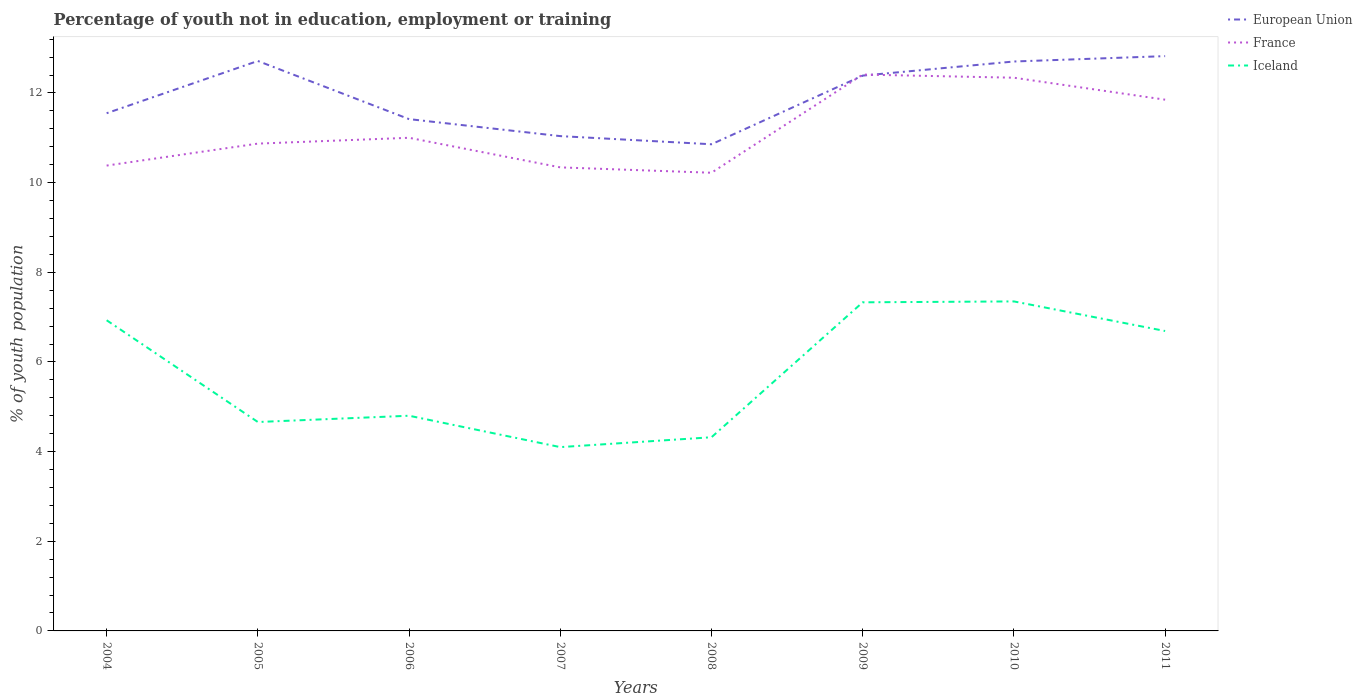Does the line corresponding to Iceland intersect with the line corresponding to France?
Provide a succinct answer. No. Across all years, what is the maximum percentage of unemployed youth population in in European Union?
Give a very brief answer. 10.86. What is the total percentage of unemployed youth population in in Iceland in the graph?
Keep it short and to the point. -2.03. What is the difference between the highest and the second highest percentage of unemployed youth population in in European Union?
Give a very brief answer. 1.97. How many lines are there?
Offer a very short reply. 3. How many years are there in the graph?
Ensure brevity in your answer.  8. Are the values on the major ticks of Y-axis written in scientific E-notation?
Give a very brief answer. No. Where does the legend appear in the graph?
Offer a terse response. Top right. What is the title of the graph?
Your answer should be very brief. Percentage of youth not in education, employment or training. What is the label or title of the Y-axis?
Your response must be concise. % of youth population. What is the % of youth population of European Union in 2004?
Ensure brevity in your answer.  11.55. What is the % of youth population in France in 2004?
Provide a succinct answer. 10.38. What is the % of youth population in Iceland in 2004?
Your answer should be compact. 6.93. What is the % of youth population in European Union in 2005?
Provide a succinct answer. 12.71. What is the % of youth population of France in 2005?
Your response must be concise. 10.87. What is the % of youth population in Iceland in 2005?
Give a very brief answer. 4.66. What is the % of youth population in European Union in 2006?
Offer a terse response. 11.42. What is the % of youth population in Iceland in 2006?
Ensure brevity in your answer.  4.8. What is the % of youth population of European Union in 2007?
Keep it short and to the point. 11.04. What is the % of youth population of France in 2007?
Offer a very short reply. 10.34. What is the % of youth population in Iceland in 2007?
Offer a terse response. 4.1. What is the % of youth population of European Union in 2008?
Your response must be concise. 10.86. What is the % of youth population of France in 2008?
Offer a very short reply. 10.22. What is the % of youth population in Iceland in 2008?
Offer a terse response. 4.32. What is the % of youth population of European Union in 2009?
Your answer should be very brief. 12.39. What is the % of youth population in France in 2009?
Offer a very short reply. 12.41. What is the % of youth population of Iceland in 2009?
Ensure brevity in your answer.  7.33. What is the % of youth population in European Union in 2010?
Make the answer very short. 12.7. What is the % of youth population in France in 2010?
Your answer should be very brief. 12.34. What is the % of youth population in Iceland in 2010?
Keep it short and to the point. 7.35. What is the % of youth population in European Union in 2011?
Your answer should be compact. 12.82. What is the % of youth population in France in 2011?
Provide a succinct answer. 11.85. What is the % of youth population of Iceland in 2011?
Your answer should be very brief. 6.69. Across all years, what is the maximum % of youth population in European Union?
Your answer should be very brief. 12.82. Across all years, what is the maximum % of youth population in France?
Give a very brief answer. 12.41. Across all years, what is the maximum % of youth population in Iceland?
Ensure brevity in your answer.  7.35. Across all years, what is the minimum % of youth population of European Union?
Make the answer very short. 10.86. Across all years, what is the minimum % of youth population of France?
Give a very brief answer. 10.22. Across all years, what is the minimum % of youth population of Iceland?
Your answer should be very brief. 4.1. What is the total % of youth population in European Union in the graph?
Offer a terse response. 95.48. What is the total % of youth population in France in the graph?
Your answer should be very brief. 89.41. What is the total % of youth population of Iceland in the graph?
Your answer should be very brief. 46.18. What is the difference between the % of youth population of European Union in 2004 and that in 2005?
Provide a short and direct response. -1.17. What is the difference between the % of youth population of France in 2004 and that in 2005?
Offer a terse response. -0.49. What is the difference between the % of youth population in Iceland in 2004 and that in 2005?
Ensure brevity in your answer.  2.27. What is the difference between the % of youth population in European Union in 2004 and that in 2006?
Give a very brief answer. 0.13. What is the difference between the % of youth population of France in 2004 and that in 2006?
Offer a terse response. -0.62. What is the difference between the % of youth population of Iceland in 2004 and that in 2006?
Your answer should be compact. 2.13. What is the difference between the % of youth population of European Union in 2004 and that in 2007?
Offer a terse response. 0.51. What is the difference between the % of youth population of Iceland in 2004 and that in 2007?
Keep it short and to the point. 2.83. What is the difference between the % of youth population in European Union in 2004 and that in 2008?
Your answer should be very brief. 0.69. What is the difference between the % of youth population in France in 2004 and that in 2008?
Your response must be concise. 0.16. What is the difference between the % of youth population in Iceland in 2004 and that in 2008?
Your response must be concise. 2.61. What is the difference between the % of youth population of European Union in 2004 and that in 2009?
Your answer should be compact. -0.84. What is the difference between the % of youth population in France in 2004 and that in 2009?
Your answer should be compact. -2.03. What is the difference between the % of youth population in European Union in 2004 and that in 2010?
Provide a succinct answer. -1.15. What is the difference between the % of youth population in France in 2004 and that in 2010?
Offer a very short reply. -1.96. What is the difference between the % of youth population of Iceland in 2004 and that in 2010?
Keep it short and to the point. -0.42. What is the difference between the % of youth population of European Union in 2004 and that in 2011?
Your answer should be compact. -1.27. What is the difference between the % of youth population of France in 2004 and that in 2011?
Your response must be concise. -1.47. What is the difference between the % of youth population of Iceland in 2004 and that in 2011?
Offer a terse response. 0.24. What is the difference between the % of youth population in European Union in 2005 and that in 2006?
Your response must be concise. 1.3. What is the difference between the % of youth population in France in 2005 and that in 2006?
Provide a short and direct response. -0.13. What is the difference between the % of youth population of Iceland in 2005 and that in 2006?
Make the answer very short. -0.14. What is the difference between the % of youth population in European Union in 2005 and that in 2007?
Keep it short and to the point. 1.68. What is the difference between the % of youth population in France in 2005 and that in 2007?
Provide a short and direct response. 0.53. What is the difference between the % of youth population of Iceland in 2005 and that in 2007?
Ensure brevity in your answer.  0.56. What is the difference between the % of youth population of European Union in 2005 and that in 2008?
Your answer should be compact. 1.86. What is the difference between the % of youth population of France in 2005 and that in 2008?
Offer a very short reply. 0.65. What is the difference between the % of youth population in Iceland in 2005 and that in 2008?
Give a very brief answer. 0.34. What is the difference between the % of youth population in European Union in 2005 and that in 2009?
Provide a succinct answer. 0.33. What is the difference between the % of youth population in France in 2005 and that in 2009?
Provide a short and direct response. -1.54. What is the difference between the % of youth population in Iceland in 2005 and that in 2009?
Provide a short and direct response. -2.67. What is the difference between the % of youth population of European Union in 2005 and that in 2010?
Give a very brief answer. 0.01. What is the difference between the % of youth population of France in 2005 and that in 2010?
Provide a short and direct response. -1.47. What is the difference between the % of youth population in Iceland in 2005 and that in 2010?
Make the answer very short. -2.69. What is the difference between the % of youth population in European Union in 2005 and that in 2011?
Your answer should be very brief. -0.11. What is the difference between the % of youth population of France in 2005 and that in 2011?
Your answer should be very brief. -0.98. What is the difference between the % of youth population in Iceland in 2005 and that in 2011?
Your answer should be very brief. -2.03. What is the difference between the % of youth population of European Union in 2006 and that in 2007?
Provide a short and direct response. 0.38. What is the difference between the % of youth population in France in 2006 and that in 2007?
Ensure brevity in your answer.  0.66. What is the difference between the % of youth population of European Union in 2006 and that in 2008?
Give a very brief answer. 0.56. What is the difference between the % of youth population of France in 2006 and that in 2008?
Keep it short and to the point. 0.78. What is the difference between the % of youth population of Iceland in 2006 and that in 2008?
Your answer should be very brief. 0.48. What is the difference between the % of youth population of European Union in 2006 and that in 2009?
Offer a very short reply. -0.97. What is the difference between the % of youth population in France in 2006 and that in 2009?
Provide a short and direct response. -1.41. What is the difference between the % of youth population in Iceland in 2006 and that in 2009?
Make the answer very short. -2.53. What is the difference between the % of youth population in European Union in 2006 and that in 2010?
Provide a short and direct response. -1.29. What is the difference between the % of youth population of France in 2006 and that in 2010?
Give a very brief answer. -1.34. What is the difference between the % of youth population in Iceland in 2006 and that in 2010?
Offer a terse response. -2.55. What is the difference between the % of youth population of European Union in 2006 and that in 2011?
Give a very brief answer. -1.41. What is the difference between the % of youth population of France in 2006 and that in 2011?
Your answer should be compact. -0.85. What is the difference between the % of youth population of Iceland in 2006 and that in 2011?
Make the answer very short. -1.89. What is the difference between the % of youth population in European Union in 2007 and that in 2008?
Ensure brevity in your answer.  0.18. What is the difference between the % of youth population in France in 2007 and that in 2008?
Make the answer very short. 0.12. What is the difference between the % of youth population in Iceland in 2007 and that in 2008?
Your answer should be compact. -0.22. What is the difference between the % of youth population of European Union in 2007 and that in 2009?
Make the answer very short. -1.35. What is the difference between the % of youth population of France in 2007 and that in 2009?
Keep it short and to the point. -2.07. What is the difference between the % of youth population of Iceland in 2007 and that in 2009?
Provide a succinct answer. -3.23. What is the difference between the % of youth population in European Union in 2007 and that in 2010?
Your answer should be compact. -1.66. What is the difference between the % of youth population in France in 2007 and that in 2010?
Give a very brief answer. -2. What is the difference between the % of youth population in Iceland in 2007 and that in 2010?
Provide a succinct answer. -3.25. What is the difference between the % of youth population in European Union in 2007 and that in 2011?
Offer a terse response. -1.78. What is the difference between the % of youth population in France in 2007 and that in 2011?
Offer a terse response. -1.51. What is the difference between the % of youth population of Iceland in 2007 and that in 2011?
Keep it short and to the point. -2.59. What is the difference between the % of youth population in European Union in 2008 and that in 2009?
Offer a very short reply. -1.53. What is the difference between the % of youth population of France in 2008 and that in 2009?
Give a very brief answer. -2.19. What is the difference between the % of youth population of Iceland in 2008 and that in 2009?
Your response must be concise. -3.01. What is the difference between the % of youth population of European Union in 2008 and that in 2010?
Ensure brevity in your answer.  -1.85. What is the difference between the % of youth population in France in 2008 and that in 2010?
Provide a succinct answer. -2.12. What is the difference between the % of youth population in Iceland in 2008 and that in 2010?
Provide a short and direct response. -3.03. What is the difference between the % of youth population of European Union in 2008 and that in 2011?
Ensure brevity in your answer.  -1.97. What is the difference between the % of youth population of France in 2008 and that in 2011?
Make the answer very short. -1.63. What is the difference between the % of youth population of Iceland in 2008 and that in 2011?
Offer a very short reply. -2.37. What is the difference between the % of youth population in European Union in 2009 and that in 2010?
Ensure brevity in your answer.  -0.31. What is the difference between the % of youth population of France in 2009 and that in 2010?
Ensure brevity in your answer.  0.07. What is the difference between the % of youth population in Iceland in 2009 and that in 2010?
Make the answer very short. -0.02. What is the difference between the % of youth population of European Union in 2009 and that in 2011?
Make the answer very short. -0.43. What is the difference between the % of youth population in France in 2009 and that in 2011?
Provide a short and direct response. 0.56. What is the difference between the % of youth population of Iceland in 2009 and that in 2011?
Offer a very short reply. 0.64. What is the difference between the % of youth population of European Union in 2010 and that in 2011?
Offer a very short reply. -0.12. What is the difference between the % of youth population in France in 2010 and that in 2011?
Your answer should be compact. 0.49. What is the difference between the % of youth population in Iceland in 2010 and that in 2011?
Ensure brevity in your answer.  0.66. What is the difference between the % of youth population of European Union in 2004 and the % of youth population of France in 2005?
Your response must be concise. 0.68. What is the difference between the % of youth population in European Union in 2004 and the % of youth population in Iceland in 2005?
Give a very brief answer. 6.89. What is the difference between the % of youth population of France in 2004 and the % of youth population of Iceland in 2005?
Keep it short and to the point. 5.72. What is the difference between the % of youth population of European Union in 2004 and the % of youth population of France in 2006?
Provide a succinct answer. 0.55. What is the difference between the % of youth population in European Union in 2004 and the % of youth population in Iceland in 2006?
Ensure brevity in your answer.  6.75. What is the difference between the % of youth population of France in 2004 and the % of youth population of Iceland in 2006?
Your answer should be very brief. 5.58. What is the difference between the % of youth population in European Union in 2004 and the % of youth population in France in 2007?
Keep it short and to the point. 1.21. What is the difference between the % of youth population in European Union in 2004 and the % of youth population in Iceland in 2007?
Your answer should be very brief. 7.45. What is the difference between the % of youth population in France in 2004 and the % of youth population in Iceland in 2007?
Make the answer very short. 6.28. What is the difference between the % of youth population of European Union in 2004 and the % of youth population of France in 2008?
Keep it short and to the point. 1.33. What is the difference between the % of youth population of European Union in 2004 and the % of youth population of Iceland in 2008?
Provide a short and direct response. 7.23. What is the difference between the % of youth population in France in 2004 and the % of youth population in Iceland in 2008?
Offer a terse response. 6.06. What is the difference between the % of youth population of European Union in 2004 and the % of youth population of France in 2009?
Your answer should be very brief. -0.86. What is the difference between the % of youth population in European Union in 2004 and the % of youth population in Iceland in 2009?
Keep it short and to the point. 4.22. What is the difference between the % of youth population of France in 2004 and the % of youth population of Iceland in 2009?
Offer a very short reply. 3.05. What is the difference between the % of youth population of European Union in 2004 and the % of youth population of France in 2010?
Your response must be concise. -0.79. What is the difference between the % of youth population of European Union in 2004 and the % of youth population of Iceland in 2010?
Your answer should be compact. 4.2. What is the difference between the % of youth population of France in 2004 and the % of youth population of Iceland in 2010?
Keep it short and to the point. 3.03. What is the difference between the % of youth population of European Union in 2004 and the % of youth population of France in 2011?
Offer a terse response. -0.3. What is the difference between the % of youth population of European Union in 2004 and the % of youth population of Iceland in 2011?
Your answer should be very brief. 4.86. What is the difference between the % of youth population of France in 2004 and the % of youth population of Iceland in 2011?
Your answer should be very brief. 3.69. What is the difference between the % of youth population of European Union in 2005 and the % of youth population of France in 2006?
Give a very brief answer. 1.71. What is the difference between the % of youth population in European Union in 2005 and the % of youth population in Iceland in 2006?
Ensure brevity in your answer.  7.91. What is the difference between the % of youth population of France in 2005 and the % of youth population of Iceland in 2006?
Make the answer very short. 6.07. What is the difference between the % of youth population in European Union in 2005 and the % of youth population in France in 2007?
Provide a short and direct response. 2.37. What is the difference between the % of youth population in European Union in 2005 and the % of youth population in Iceland in 2007?
Your answer should be compact. 8.61. What is the difference between the % of youth population of France in 2005 and the % of youth population of Iceland in 2007?
Your answer should be very brief. 6.77. What is the difference between the % of youth population in European Union in 2005 and the % of youth population in France in 2008?
Your answer should be compact. 2.49. What is the difference between the % of youth population in European Union in 2005 and the % of youth population in Iceland in 2008?
Offer a terse response. 8.39. What is the difference between the % of youth population in France in 2005 and the % of youth population in Iceland in 2008?
Give a very brief answer. 6.55. What is the difference between the % of youth population of European Union in 2005 and the % of youth population of France in 2009?
Ensure brevity in your answer.  0.3. What is the difference between the % of youth population of European Union in 2005 and the % of youth population of Iceland in 2009?
Offer a terse response. 5.38. What is the difference between the % of youth population in France in 2005 and the % of youth population in Iceland in 2009?
Your response must be concise. 3.54. What is the difference between the % of youth population of European Union in 2005 and the % of youth population of France in 2010?
Keep it short and to the point. 0.37. What is the difference between the % of youth population in European Union in 2005 and the % of youth population in Iceland in 2010?
Your answer should be very brief. 5.36. What is the difference between the % of youth population of France in 2005 and the % of youth population of Iceland in 2010?
Your response must be concise. 3.52. What is the difference between the % of youth population of European Union in 2005 and the % of youth population of France in 2011?
Make the answer very short. 0.86. What is the difference between the % of youth population in European Union in 2005 and the % of youth population in Iceland in 2011?
Offer a very short reply. 6.02. What is the difference between the % of youth population of France in 2005 and the % of youth population of Iceland in 2011?
Make the answer very short. 4.18. What is the difference between the % of youth population in European Union in 2006 and the % of youth population in France in 2007?
Offer a very short reply. 1.08. What is the difference between the % of youth population in European Union in 2006 and the % of youth population in Iceland in 2007?
Provide a succinct answer. 7.32. What is the difference between the % of youth population of European Union in 2006 and the % of youth population of France in 2008?
Your answer should be very brief. 1.2. What is the difference between the % of youth population in European Union in 2006 and the % of youth population in Iceland in 2008?
Your answer should be very brief. 7.1. What is the difference between the % of youth population in France in 2006 and the % of youth population in Iceland in 2008?
Ensure brevity in your answer.  6.68. What is the difference between the % of youth population of European Union in 2006 and the % of youth population of France in 2009?
Ensure brevity in your answer.  -0.99. What is the difference between the % of youth population in European Union in 2006 and the % of youth population in Iceland in 2009?
Give a very brief answer. 4.09. What is the difference between the % of youth population of France in 2006 and the % of youth population of Iceland in 2009?
Your answer should be compact. 3.67. What is the difference between the % of youth population in European Union in 2006 and the % of youth population in France in 2010?
Offer a terse response. -0.92. What is the difference between the % of youth population of European Union in 2006 and the % of youth population of Iceland in 2010?
Your response must be concise. 4.07. What is the difference between the % of youth population in France in 2006 and the % of youth population in Iceland in 2010?
Ensure brevity in your answer.  3.65. What is the difference between the % of youth population in European Union in 2006 and the % of youth population in France in 2011?
Your answer should be very brief. -0.43. What is the difference between the % of youth population of European Union in 2006 and the % of youth population of Iceland in 2011?
Provide a short and direct response. 4.73. What is the difference between the % of youth population of France in 2006 and the % of youth population of Iceland in 2011?
Offer a very short reply. 4.31. What is the difference between the % of youth population of European Union in 2007 and the % of youth population of France in 2008?
Offer a terse response. 0.82. What is the difference between the % of youth population of European Union in 2007 and the % of youth population of Iceland in 2008?
Ensure brevity in your answer.  6.72. What is the difference between the % of youth population in France in 2007 and the % of youth population in Iceland in 2008?
Provide a short and direct response. 6.02. What is the difference between the % of youth population of European Union in 2007 and the % of youth population of France in 2009?
Provide a succinct answer. -1.37. What is the difference between the % of youth population in European Union in 2007 and the % of youth population in Iceland in 2009?
Your answer should be compact. 3.71. What is the difference between the % of youth population in France in 2007 and the % of youth population in Iceland in 2009?
Offer a terse response. 3.01. What is the difference between the % of youth population in European Union in 2007 and the % of youth population in France in 2010?
Offer a very short reply. -1.3. What is the difference between the % of youth population of European Union in 2007 and the % of youth population of Iceland in 2010?
Give a very brief answer. 3.69. What is the difference between the % of youth population in France in 2007 and the % of youth population in Iceland in 2010?
Ensure brevity in your answer.  2.99. What is the difference between the % of youth population of European Union in 2007 and the % of youth population of France in 2011?
Ensure brevity in your answer.  -0.81. What is the difference between the % of youth population of European Union in 2007 and the % of youth population of Iceland in 2011?
Offer a very short reply. 4.35. What is the difference between the % of youth population in France in 2007 and the % of youth population in Iceland in 2011?
Provide a succinct answer. 3.65. What is the difference between the % of youth population of European Union in 2008 and the % of youth population of France in 2009?
Offer a very short reply. -1.55. What is the difference between the % of youth population in European Union in 2008 and the % of youth population in Iceland in 2009?
Your answer should be very brief. 3.53. What is the difference between the % of youth population of France in 2008 and the % of youth population of Iceland in 2009?
Your response must be concise. 2.89. What is the difference between the % of youth population of European Union in 2008 and the % of youth population of France in 2010?
Your response must be concise. -1.48. What is the difference between the % of youth population in European Union in 2008 and the % of youth population in Iceland in 2010?
Your answer should be very brief. 3.51. What is the difference between the % of youth population in France in 2008 and the % of youth population in Iceland in 2010?
Your response must be concise. 2.87. What is the difference between the % of youth population of European Union in 2008 and the % of youth population of France in 2011?
Give a very brief answer. -0.99. What is the difference between the % of youth population in European Union in 2008 and the % of youth population in Iceland in 2011?
Offer a very short reply. 4.17. What is the difference between the % of youth population in France in 2008 and the % of youth population in Iceland in 2011?
Offer a terse response. 3.53. What is the difference between the % of youth population in European Union in 2009 and the % of youth population in France in 2010?
Ensure brevity in your answer.  0.05. What is the difference between the % of youth population in European Union in 2009 and the % of youth population in Iceland in 2010?
Offer a terse response. 5.04. What is the difference between the % of youth population in France in 2009 and the % of youth population in Iceland in 2010?
Offer a terse response. 5.06. What is the difference between the % of youth population in European Union in 2009 and the % of youth population in France in 2011?
Offer a terse response. 0.54. What is the difference between the % of youth population in European Union in 2009 and the % of youth population in Iceland in 2011?
Offer a very short reply. 5.7. What is the difference between the % of youth population in France in 2009 and the % of youth population in Iceland in 2011?
Make the answer very short. 5.72. What is the difference between the % of youth population of European Union in 2010 and the % of youth population of France in 2011?
Provide a short and direct response. 0.85. What is the difference between the % of youth population of European Union in 2010 and the % of youth population of Iceland in 2011?
Keep it short and to the point. 6.01. What is the difference between the % of youth population in France in 2010 and the % of youth population in Iceland in 2011?
Offer a very short reply. 5.65. What is the average % of youth population of European Union per year?
Your response must be concise. 11.94. What is the average % of youth population in France per year?
Give a very brief answer. 11.18. What is the average % of youth population in Iceland per year?
Offer a terse response. 5.77. In the year 2004, what is the difference between the % of youth population in European Union and % of youth population in France?
Provide a short and direct response. 1.17. In the year 2004, what is the difference between the % of youth population in European Union and % of youth population in Iceland?
Ensure brevity in your answer.  4.62. In the year 2004, what is the difference between the % of youth population in France and % of youth population in Iceland?
Your answer should be compact. 3.45. In the year 2005, what is the difference between the % of youth population in European Union and % of youth population in France?
Ensure brevity in your answer.  1.84. In the year 2005, what is the difference between the % of youth population of European Union and % of youth population of Iceland?
Your response must be concise. 8.05. In the year 2005, what is the difference between the % of youth population in France and % of youth population in Iceland?
Provide a short and direct response. 6.21. In the year 2006, what is the difference between the % of youth population in European Union and % of youth population in France?
Ensure brevity in your answer.  0.42. In the year 2006, what is the difference between the % of youth population of European Union and % of youth population of Iceland?
Your answer should be compact. 6.62. In the year 2007, what is the difference between the % of youth population of European Union and % of youth population of France?
Offer a terse response. 0.7. In the year 2007, what is the difference between the % of youth population of European Union and % of youth population of Iceland?
Offer a terse response. 6.94. In the year 2007, what is the difference between the % of youth population in France and % of youth population in Iceland?
Provide a succinct answer. 6.24. In the year 2008, what is the difference between the % of youth population in European Union and % of youth population in France?
Offer a terse response. 0.64. In the year 2008, what is the difference between the % of youth population in European Union and % of youth population in Iceland?
Ensure brevity in your answer.  6.54. In the year 2009, what is the difference between the % of youth population of European Union and % of youth population of France?
Ensure brevity in your answer.  -0.02. In the year 2009, what is the difference between the % of youth population in European Union and % of youth population in Iceland?
Your answer should be compact. 5.06. In the year 2009, what is the difference between the % of youth population in France and % of youth population in Iceland?
Offer a terse response. 5.08. In the year 2010, what is the difference between the % of youth population of European Union and % of youth population of France?
Offer a terse response. 0.36. In the year 2010, what is the difference between the % of youth population of European Union and % of youth population of Iceland?
Provide a succinct answer. 5.35. In the year 2010, what is the difference between the % of youth population of France and % of youth population of Iceland?
Your answer should be very brief. 4.99. In the year 2011, what is the difference between the % of youth population of European Union and % of youth population of France?
Your answer should be compact. 0.97. In the year 2011, what is the difference between the % of youth population in European Union and % of youth population in Iceland?
Your response must be concise. 6.13. In the year 2011, what is the difference between the % of youth population in France and % of youth population in Iceland?
Your answer should be very brief. 5.16. What is the ratio of the % of youth population of European Union in 2004 to that in 2005?
Your response must be concise. 0.91. What is the ratio of the % of youth population in France in 2004 to that in 2005?
Your answer should be very brief. 0.95. What is the ratio of the % of youth population of Iceland in 2004 to that in 2005?
Your response must be concise. 1.49. What is the ratio of the % of youth population in European Union in 2004 to that in 2006?
Ensure brevity in your answer.  1.01. What is the ratio of the % of youth population in France in 2004 to that in 2006?
Your answer should be compact. 0.94. What is the ratio of the % of youth population of Iceland in 2004 to that in 2006?
Provide a succinct answer. 1.44. What is the ratio of the % of youth population in European Union in 2004 to that in 2007?
Your answer should be very brief. 1.05. What is the ratio of the % of youth population in Iceland in 2004 to that in 2007?
Give a very brief answer. 1.69. What is the ratio of the % of youth population of European Union in 2004 to that in 2008?
Ensure brevity in your answer.  1.06. What is the ratio of the % of youth population of France in 2004 to that in 2008?
Ensure brevity in your answer.  1.02. What is the ratio of the % of youth population of Iceland in 2004 to that in 2008?
Your answer should be very brief. 1.6. What is the ratio of the % of youth population in European Union in 2004 to that in 2009?
Give a very brief answer. 0.93. What is the ratio of the % of youth population of France in 2004 to that in 2009?
Your answer should be very brief. 0.84. What is the ratio of the % of youth population in Iceland in 2004 to that in 2009?
Your response must be concise. 0.95. What is the ratio of the % of youth population of European Union in 2004 to that in 2010?
Make the answer very short. 0.91. What is the ratio of the % of youth population in France in 2004 to that in 2010?
Offer a very short reply. 0.84. What is the ratio of the % of youth population of Iceland in 2004 to that in 2010?
Offer a terse response. 0.94. What is the ratio of the % of youth population in European Union in 2004 to that in 2011?
Keep it short and to the point. 0.9. What is the ratio of the % of youth population in France in 2004 to that in 2011?
Your answer should be very brief. 0.88. What is the ratio of the % of youth population in Iceland in 2004 to that in 2011?
Offer a terse response. 1.04. What is the ratio of the % of youth population in European Union in 2005 to that in 2006?
Offer a terse response. 1.11. What is the ratio of the % of youth population in Iceland in 2005 to that in 2006?
Offer a terse response. 0.97. What is the ratio of the % of youth population in European Union in 2005 to that in 2007?
Offer a very short reply. 1.15. What is the ratio of the % of youth population in France in 2005 to that in 2007?
Your answer should be compact. 1.05. What is the ratio of the % of youth population of Iceland in 2005 to that in 2007?
Ensure brevity in your answer.  1.14. What is the ratio of the % of youth population of European Union in 2005 to that in 2008?
Ensure brevity in your answer.  1.17. What is the ratio of the % of youth population in France in 2005 to that in 2008?
Provide a short and direct response. 1.06. What is the ratio of the % of youth population of Iceland in 2005 to that in 2008?
Keep it short and to the point. 1.08. What is the ratio of the % of youth population of European Union in 2005 to that in 2009?
Keep it short and to the point. 1.03. What is the ratio of the % of youth population in France in 2005 to that in 2009?
Make the answer very short. 0.88. What is the ratio of the % of youth population in Iceland in 2005 to that in 2009?
Provide a short and direct response. 0.64. What is the ratio of the % of youth population in France in 2005 to that in 2010?
Offer a terse response. 0.88. What is the ratio of the % of youth population in Iceland in 2005 to that in 2010?
Provide a succinct answer. 0.63. What is the ratio of the % of youth population of European Union in 2005 to that in 2011?
Provide a short and direct response. 0.99. What is the ratio of the % of youth population in France in 2005 to that in 2011?
Your response must be concise. 0.92. What is the ratio of the % of youth population of Iceland in 2005 to that in 2011?
Your answer should be very brief. 0.7. What is the ratio of the % of youth population of European Union in 2006 to that in 2007?
Ensure brevity in your answer.  1.03. What is the ratio of the % of youth population of France in 2006 to that in 2007?
Ensure brevity in your answer.  1.06. What is the ratio of the % of youth population of Iceland in 2006 to that in 2007?
Your response must be concise. 1.17. What is the ratio of the % of youth population of European Union in 2006 to that in 2008?
Provide a short and direct response. 1.05. What is the ratio of the % of youth population in France in 2006 to that in 2008?
Offer a very short reply. 1.08. What is the ratio of the % of youth population in Iceland in 2006 to that in 2008?
Provide a short and direct response. 1.11. What is the ratio of the % of youth population of European Union in 2006 to that in 2009?
Your answer should be compact. 0.92. What is the ratio of the % of youth population in France in 2006 to that in 2009?
Ensure brevity in your answer.  0.89. What is the ratio of the % of youth population in Iceland in 2006 to that in 2009?
Offer a very short reply. 0.65. What is the ratio of the % of youth population in European Union in 2006 to that in 2010?
Give a very brief answer. 0.9. What is the ratio of the % of youth population of France in 2006 to that in 2010?
Provide a short and direct response. 0.89. What is the ratio of the % of youth population of Iceland in 2006 to that in 2010?
Offer a very short reply. 0.65. What is the ratio of the % of youth population in European Union in 2006 to that in 2011?
Your response must be concise. 0.89. What is the ratio of the % of youth population in France in 2006 to that in 2011?
Your response must be concise. 0.93. What is the ratio of the % of youth population in Iceland in 2006 to that in 2011?
Your answer should be compact. 0.72. What is the ratio of the % of youth population of European Union in 2007 to that in 2008?
Provide a succinct answer. 1.02. What is the ratio of the % of youth population in France in 2007 to that in 2008?
Give a very brief answer. 1.01. What is the ratio of the % of youth population of Iceland in 2007 to that in 2008?
Ensure brevity in your answer.  0.95. What is the ratio of the % of youth population of European Union in 2007 to that in 2009?
Your answer should be compact. 0.89. What is the ratio of the % of youth population in France in 2007 to that in 2009?
Offer a terse response. 0.83. What is the ratio of the % of youth population of Iceland in 2007 to that in 2009?
Make the answer very short. 0.56. What is the ratio of the % of youth population of European Union in 2007 to that in 2010?
Keep it short and to the point. 0.87. What is the ratio of the % of youth population of France in 2007 to that in 2010?
Your answer should be very brief. 0.84. What is the ratio of the % of youth population in Iceland in 2007 to that in 2010?
Your answer should be compact. 0.56. What is the ratio of the % of youth population of European Union in 2007 to that in 2011?
Offer a very short reply. 0.86. What is the ratio of the % of youth population of France in 2007 to that in 2011?
Your response must be concise. 0.87. What is the ratio of the % of youth population of Iceland in 2007 to that in 2011?
Your response must be concise. 0.61. What is the ratio of the % of youth population of European Union in 2008 to that in 2009?
Ensure brevity in your answer.  0.88. What is the ratio of the % of youth population in France in 2008 to that in 2009?
Give a very brief answer. 0.82. What is the ratio of the % of youth population in Iceland in 2008 to that in 2009?
Make the answer very short. 0.59. What is the ratio of the % of youth population of European Union in 2008 to that in 2010?
Give a very brief answer. 0.85. What is the ratio of the % of youth population in France in 2008 to that in 2010?
Offer a terse response. 0.83. What is the ratio of the % of youth population in Iceland in 2008 to that in 2010?
Provide a succinct answer. 0.59. What is the ratio of the % of youth population of European Union in 2008 to that in 2011?
Provide a succinct answer. 0.85. What is the ratio of the % of youth population of France in 2008 to that in 2011?
Your answer should be very brief. 0.86. What is the ratio of the % of youth population in Iceland in 2008 to that in 2011?
Your answer should be very brief. 0.65. What is the ratio of the % of youth population of European Union in 2009 to that in 2010?
Offer a terse response. 0.98. What is the ratio of the % of youth population of France in 2009 to that in 2010?
Make the answer very short. 1.01. What is the ratio of the % of youth population in European Union in 2009 to that in 2011?
Your answer should be compact. 0.97. What is the ratio of the % of youth population of France in 2009 to that in 2011?
Offer a very short reply. 1.05. What is the ratio of the % of youth population in Iceland in 2009 to that in 2011?
Offer a terse response. 1.1. What is the ratio of the % of youth population of France in 2010 to that in 2011?
Offer a very short reply. 1.04. What is the ratio of the % of youth population in Iceland in 2010 to that in 2011?
Keep it short and to the point. 1.1. What is the difference between the highest and the second highest % of youth population in European Union?
Provide a succinct answer. 0.11. What is the difference between the highest and the second highest % of youth population in France?
Your answer should be compact. 0.07. What is the difference between the highest and the lowest % of youth population in European Union?
Give a very brief answer. 1.97. What is the difference between the highest and the lowest % of youth population of France?
Provide a succinct answer. 2.19. What is the difference between the highest and the lowest % of youth population of Iceland?
Provide a succinct answer. 3.25. 